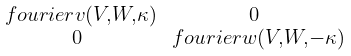Convert formula to latex. <formula><loc_0><loc_0><loc_500><loc_500>\begin{smallmatrix} \ f o u r i e r { v } ( V , W , \kappa ) & 0 \\ 0 & \ f o u r i e r { w } ( V , W , - \kappa ) \end{smallmatrix}</formula> 